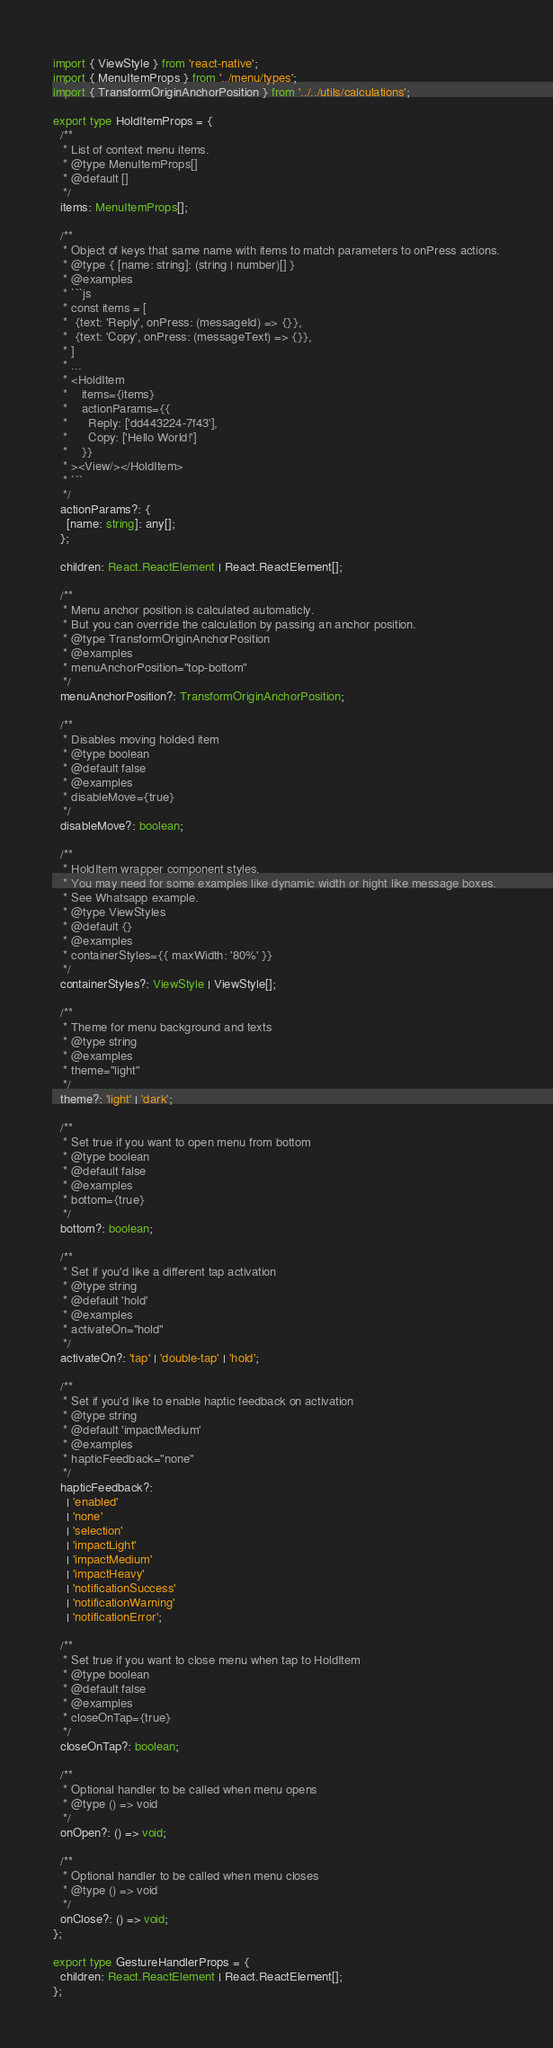Convert code to text. <code><loc_0><loc_0><loc_500><loc_500><_TypeScript_>import { ViewStyle } from 'react-native';
import { MenuItemProps } from '../menu/types';
import { TransformOriginAnchorPosition } from '../../utils/calculations';

export type HoldItemProps = {
  /**
   * List of context menu items.
   * @type MenuItemProps[]
   * @default []
   */
  items: MenuItemProps[];

  /**
   * Object of keys that same name with items to match parameters to onPress actions.
   * @type { [name: string]: (string | number)[] }
   * @examples
   * ```js
   * const items = [
   *  {text: 'Reply', onPress: (messageId) => {}},
   *  {text: 'Copy', onPress: (messageText) => {}},
   * ]
   * ...
   * <HoldItem
   *    items={items}
   *    actionParams={{
   *      Reply: ['dd443224-7f43'],
   *      Copy: ['Hello World!']
   *    }}
   * ><View/></HoldItem>
   * ```
   */
  actionParams?: {
    [name: string]: any[];
  };

  children: React.ReactElement | React.ReactElement[];

  /**
   * Menu anchor position is calculated automaticly.
   * But you can override the calculation by passing an anchor position.
   * @type TransformOriginAnchorPosition
   * @examples
   * menuAnchorPosition="top-bottom"
   */
  menuAnchorPosition?: TransformOriginAnchorPosition;

  /**
   * Disables moving holded item
   * @type boolean
   * @default false
   * @examples
   * disableMove={true}
   */
  disableMove?: boolean;

  /**
   * HoldItem wrapper component styles.
   * You may need for some examples like dynamic width or hight like message boxes.
   * See Whatsapp example.
   * @type ViewStyles
   * @default {}
   * @examples
   * containerStyles={{ maxWidth: '80%' }}
   */
  containerStyles?: ViewStyle | ViewStyle[];

  /**
   * Theme for menu background and texts
   * @type string
   * @examples
   * theme="light"
   */
  theme?: 'light' | 'dark';

  /**
   * Set true if you want to open menu from bottom
   * @type boolean
   * @default false
   * @examples
   * bottom={true}
   */
  bottom?: boolean;

  /**
   * Set if you'd like a different tap activation
   * @type string
   * @default 'hold'
   * @examples
   * activateOn="hold"
   */
  activateOn?: 'tap' | 'double-tap' | 'hold';

  /**
   * Set if you'd like to enable haptic feedback on activation
   * @type string
   * @default 'impactMedium'
   * @examples
   * hapticFeedback="none"
   */
  hapticFeedback?:
    | 'enabled'
    | 'none'
    | 'selection'
    | 'impactLight'
    | 'impactMedium'
    | 'impactHeavy'
    | 'notificationSuccess'
    | 'notificationWarning'
    | 'notificationError';

  /**
   * Set true if you want to close menu when tap to HoldItem
   * @type boolean
   * @default false
   * @examples
   * closeOnTap={true}
   */
  closeOnTap?: boolean;

  /**
   * Optional handler to be called when menu opens
   * @type () => void
   */
  onOpen?: () => void;

  /**
   * Optional handler to be called when menu closes
   * @type () => void
   */
  onClose?: () => void;
};

export type GestureHandlerProps = {
  children: React.ReactElement | React.ReactElement[];
};
</code> 